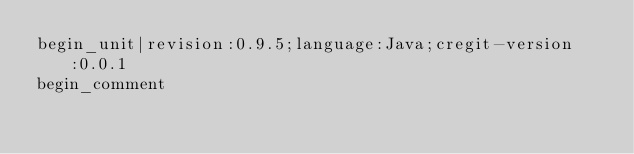<code> <loc_0><loc_0><loc_500><loc_500><_Java_>begin_unit|revision:0.9.5;language:Java;cregit-version:0.0.1
begin_comment</code> 